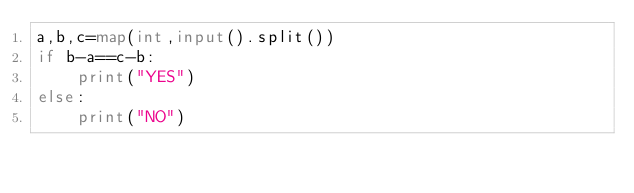Convert code to text. <code><loc_0><loc_0><loc_500><loc_500><_Python_>a,b,c=map(int,input().split())
if b-a==c-b:
    print("YES")
else:
    print("NO")</code> 